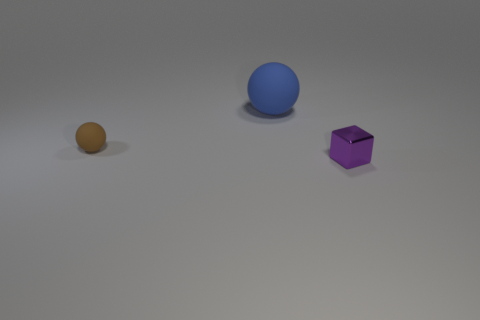Are there any green metallic balls that have the same size as the brown matte sphere?
Ensure brevity in your answer.  No. What number of big rubber balls are behind the small thing that is to the right of the large rubber ball?
Your response must be concise. 1. What is the material of the small purple block?
Your response must be concise. Metal. There is a small rubber object; how many large blue objects are right of it?
Offer a terse response. 1. Is the number of large gray spheres greater than the number of matte things?
Keep it short and to the point. No. How big is the object that is in front of the blue rubber object and left of the small purple metallic cube?
Your answer should be compact. Small. Is the material of the small object that is behind the metal cube the same as the sphere that is right of the tiny brown ball?
Your response must be concise. Yes. There is a rubber object that is the same size as the shiny thing; what is its shape?
Offer a very short reply. Sphere. Are there fewer shiny objects than rubber spheres?
Provide a succinct answer. Yes. There is a rubber ball in front of the big blue sphere; is there a big matte sphere behind it?
Give a very brief answer. Yes. 